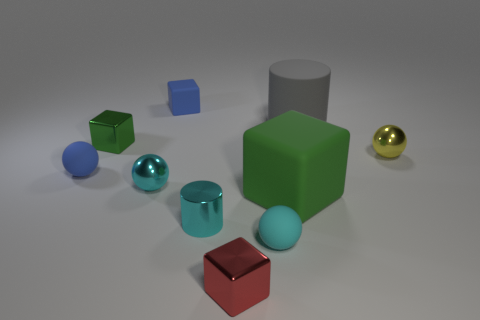There is a tiny block that is the same color as the large matte block; what is its material?
Provide a short and direct response. Metal. How many objects are big rubber cylinders or green matte blocks?
Your answer should be compact. 2. Does the matte block on the left side of the cyan rubber object have the same size as the green thing that is in front of the cyan shiny sphere?
Your answer should be compact. No. How many blocks are gray objects or large things?
Make the answer very short. 1. Is there a large purple metal ball?
Keep it short and to the point. No. How many things are spheres that are on the left side of the green metallic thing or small things?
Provide a short and direct response. 8. What number of cyan metal spheres are to the right of the small cyan ball that is on the right side of the thing that is in front of the tiny cyan rubber ball?
Your response must be concise. 0. What shape is the green object that is in front of the metallic block that is behind the rubber sphere that is on the right side of the small red object?
Your response must be concise. Cube. What number of other things are there of the same color as the large matte cube?
Your answer should be compact. 1. The blue thing to the right of the green thing that is behind the large matte block is what shape?
Give a very brief answer. Cube. 